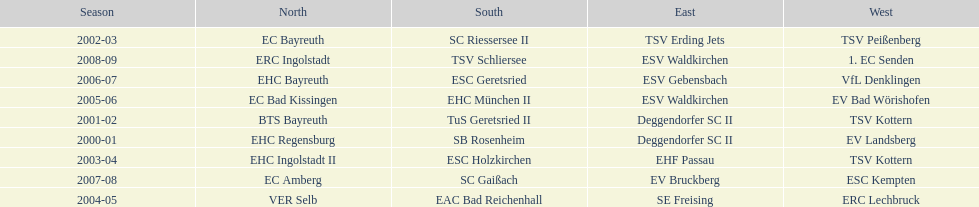What was the first club for the north in the 2000's? EHC Regensburg. 